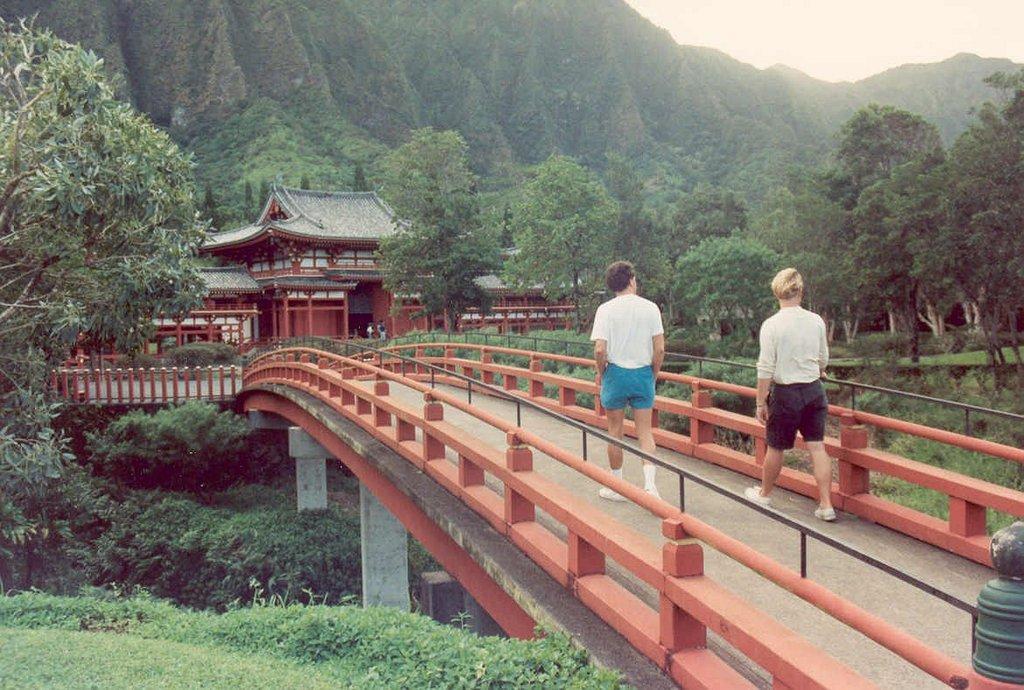In one or two sentences, can you explain what this image depicts? In the picture we can see a forest with full of plants and on it we can see a walking bridge with two people are walking on it and besides the bridge we can see railings to it and far away from it we can see a house with some people standing near it and around the house we can see full of plants and trees and in the background we can see hills are covered with plants and trees and behind it we can see sky. 